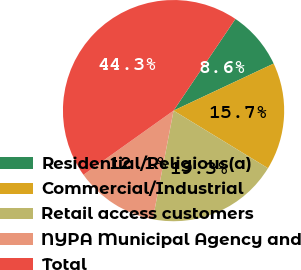<chart> <loc_0><loc_0><loc_500><loc_500><pie_chart><fcel>Residential/Religious(a)<fcel>Commercial/Industrial<fcel>Retail access customers<fcel>NYPA Municipal Agency and<fcel>Total<nl><fcel>8.56%<fcel>15.71%<fcel>19.29%<fcel>12.14%<fcel>44.3%<nl></chart> 